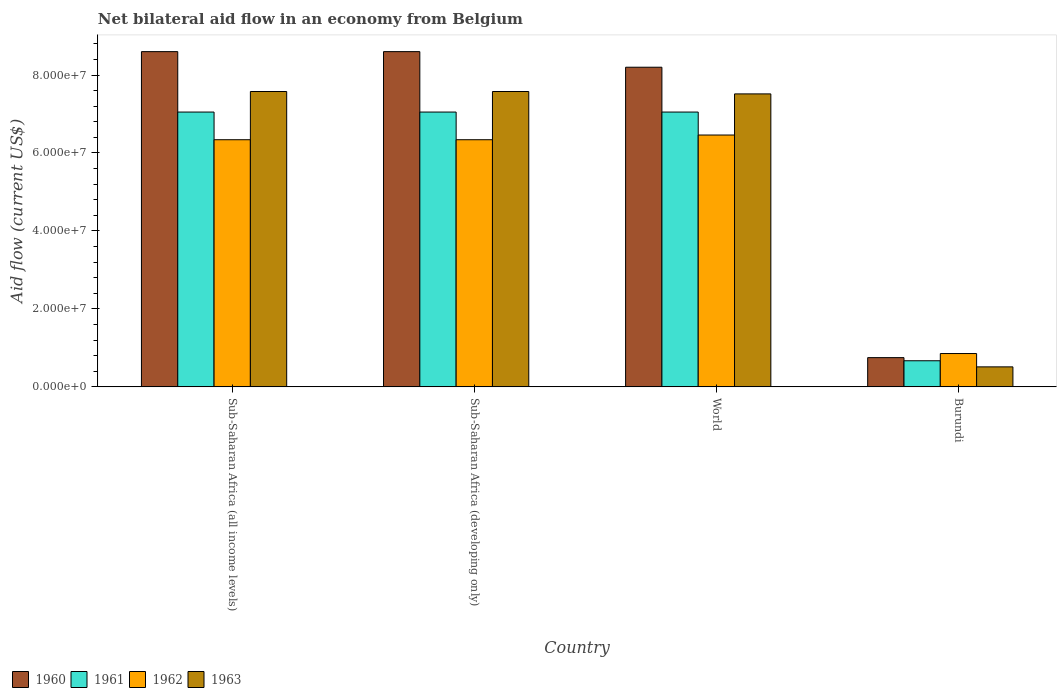How many different coloured bars are there?
Your answer should be very brief. 4. How many groups of bars are there?
Your response must be concise. 4. Are the number of bars per tick equal to the number of legend labels?
Offer a terse response. Yes. Are the number of bars on each tick of the X-axis equal?
Offer a terse response. Yes. In how many cases, is the number of bars for a given country not equal to the number of legend labels?
Make the answer very short. 0. What is the net bilateral aid flow in 1960 in Sub-Saharan Africa (all income levels)?
Provide a succinct answer. 8.60e+07. Across all countries, what is the maximum net bilateral aid flow in 1963?
Your response must be concise. 7.58e+07. Across all countries, what is the minimum net bilateral aid flow in 1963?
Your response must be concise. 5.13e+06. In which country was the net bilateral aid flow in 1962 maximum?
Your answer should be compact. World. In which country was the net bilateral aid flow in 1963 minimum?
Your response must be concise. Burundi. What is the total net bilateral aid flow in 1962 in the graph?
Provide a short and direct response. 2.00e+08. What is the difference between the net bilateral aid flow in 1961 in Sub-Saharan Africa (all income levels) and the net bilateral aid flow in 1960 in Sub-Saharan Africa (developing only)?
Your response must be concise. -1.55e+07. What is the average net bilateral aid flow in 1961 per country?
Provide a succinct answer. 5.46e+07. What is the difference between the net bilateral aid flow of/in 1961 and net bilateral aid flow of/in 1960 in Sub-Saharan Africa (all income levels)?
Ensure brevity in your answer.  -1.55e+07. What is the ratio of the net bilateral aid flow in 1961 in Burundi to that in World?
Your answer should be very brief. 0.1. Is the net bilateral aid flow in 1960 in Burundi less than that in Sub-Saharan Africa (developing only)?
Ensure brevity in your answer.  Yes. Is the difference between the net bilateral aid flow in 1961 in Sub-Saharan Africa (developing only) and World greater than the difference between the net bilateral aid flow in 1960 in Sub-Saharan Africa (developing only) and World?
Offer a very short reply. No. What is the difference between the highest and the second highest net bilateral aid flow in 1960?
Your answer should be compact. 4.00e+06. What is the difference between the highest and the lowest net bilateral aid flow in 1963?
Provide a short and direct response. 7.06e+07. In how many countries, is the net bilateral aid flow in 1961 greater than the average net bilateral aid flow in 1961 taken over all countries?
Your answer should be compact. 3. Is the sum of the net bilateral aid flow in 1960 in Burundi and Sub-Saharan Africa (developing only) greater than the maximum net bilateral aid flow in 1963 across all countries?
Offer a terse response. Yes. Is it the case that in every country, the sum of the net bilateral aid flow in 1960 and net bilateral aid flow in 1962 is greater than the sum of net bilateral aid flow in 1961 and net bilateral aid flow in 1963?
Make the answer very short. No. What does the 2nd bar from the left in Sub-Saharan Africa (all income levels) represents?
Ensure brevity in your answer.  1961. What does the 2nd bar from the right in Burundi represents?
Keep it short and to the point. 1962. Is it the case that in every country, the sum of the net bilateral aid flow in 1960 and net bilateral aid flow in 1961 is greater than the net bilateral aid flow in 1962?
Give a very brief answer. Yes. How many countries are there in the graph?
Provide a short and direct response. 4. What is the difference between two consecutive major ticks on the Y-axis?
Offer a very short reply. 2.00e+07. Does the graph contain any zero values?
Your answer should be very brief. No. Does the graph contain grids?
Give a very brief answer. No. How many legend labels are there?
Provide a succinct answer. 4. How are the legend labels stacked?
Make the answer very short. Horizontal. What is the title of the graph?
Offer a terse response. Net bilateral aid flow in an economy from Belgium. What is the label or title of the X-axis?
Provide a succinct answer. Country. What is the Aid flow (current US$) in 1960 in Sub-Saharan Africa (all income levels)?
Your answer should be compact. 8.60e+07. What is the Aid flow (current US$) of 1961 in Sub-Saharan Africa (all income levels)?
Offer a very short reply. 7.05e+07. What is the Aid flow (current US$) of 1962 in Sub-Saharan Africa (all income levels)?
Ensure brevity in your answer.  6.34e+07. What is the Aid flow (current US$) of 1963 in Sub-Saharan Africa (all income levels)?
Your response must be concise. 7.58e+07. What is the Aid flow (current US$) of 1960 in Sub-Saharan Africa (developing only)?
Provide a succinct answer. 8.60e+07. What is the Aid flow (current US$) of 1961 in Sub-Saharan Africa (developing only)?
Give a very brief answer. 7.05e+07. What is the Aid flow (current US$) in 1962 in Sub-Saharan Africa (developing only)?
Offer a terse response. 6.34e+07. What is the Aid flow (current US$) in 1963 in Sub-Saharan Africa (developing only)?
Offer a terse response. 7.58e+07. What is the Aid flow (current US$) of 1960 in World?
Offer a terse response. 8.20e+07. What is the Aid flow (current US$) of 1961 in World?
Your answer should be compact. 7.05e+07. What is the Aid flow (current US$) of 1962 in World?
Offer a very short reply. 6.46e+07. What is the Aid flow (current US$) in 1963 in World?
Your answer should be very brief. 7.52e+07. What is the Aid flow (current US$) of 1960 in Burundi?
Offer a very short reply. 7.50e+06. What is the Aid flow (current US$) in 1961 in Burundi?
Keep it short and to the point. 6.70e+06. What is the Aid flow (current US$) in 1962 in Burundi?
Ensure brevity in your answer.  8.55e+06. What is the Aid flow (current US$) of 1963 in Burundi?
Offer a very short reply. 5.13e+06. Across all countries, what is the maximum Aid flow (current US$) of 1960?
Offer a very short reply. 8.60e+07. Across all countries, what is the maximum Aid flow (current US$) in 1961?
Offer a terse response. 7.05e+07. Across all countries, what is the maximum Aid flow (current US$) of 1962?
Ensure brevity in your answer.  6.46e+07. Across all countries, what is the maximum Aid flow (current US$) of 1963?
Ensure brevity in your answer.  7.58e+07. Across all countries, what is the minimum Aid flow (current US$) of 1960?
Your response must be concise. 7.50e+06. Across all countries, what is the minimum Aid flow (current US$) in 1961?
Offer a very short reply. 6.70e+06. Across all countries, what is the minimum Aid flow (current US$) in 1962?
Offer a terse response. 8.55e+06. Across all countries, what is the minimum Aid flow (current US$) in 1963?
Ensure brevity in your answer.  5.13e+06. What is the total Aid flow (current US$) of 1960 in the graph?
Provide a succinct answer. 2.62e+08. What is the total Aid flow (current US$) of 1961 in the graph?
Your answer should be compact. 2.18e+08. What is the total Aid flow (current US$) of 1962 in the graph?
Ensure brevity in your answer.  2.00e+08. What is the total Aid flow (current US$) in 1963 in the graph?
Keep it short and to the point. 2.32e+08. What is the difference between the Aid flow (current US$) of 1960 in Sub-Saharan Africa (all income levels) and that in Sub-Saharan Africa (developing only)?
Your response must be concise. 0. What is the difference between the Aid flow (current US$) in 1961 in Sub-Saharan Africa (all income levels) and that in Sub-Saharan Africa (developing only)?
Ensure brevity in your answer.  0. What is the difference between the Aid flow (current US$) of 1962 in Sub-Saharan Africa (all income levels) and that in Sub-Saharan Africa (developing only)?
Offer a terse response. 0. What is the difference between the Aid flow (current US$) of 1963 in Sub-Saharan Africa (all income levels) and that in Sub-Saharan Africa (developing only)?
Ensure brevity in your answer.  0. What is the difference between the Aid flow (current US$) in 1960 in Sub-Saharan Africa (all income levels) and that in World?
Give a very brief answer. 4.00e+06. What is the difference between the Aid flow (current US$) of 1961 in Sub-Saharan Africa (all income levels) and that in World?
Give a very brief answer. 0. What is the difference between the Aid flow (current US$) in 1962 in Sub-Saharan Africa (all income levels) and that in World?
Provide a succinct answer. -1.21e+06. What is the difference between the Aid flow (current US$) in 1963 in Sub-Saharan Africa (all income levels) and that in World?
Provide a succinct answer. 6.10e+05. What is the difference between the Aid flow (current US$) of 1960 in Sub-Saharan Africa (all income levels) and that in Burundi?
Give a very brief answer. 7.85e+07. What is the difference between the Aid flow (current US$) in 1961 in Sub-Saharan Africa (all income levels) and that in Burundi?
Provide a short and direct response. 6.38e+07. What is the difference between the Aid flow (current US$) in 1962 in Sub-Saharan Africa (all income levels) and that in Burundi?
Your answer should be very brief. 5.48e+07. What is the difference between the Aid flow (current US$) in 1963 in Sub-Saharan Africa (all income levels) and that in Burundi?
Provide a succinct answer. 7.06e+07. What is the difference between the Aid flow (current US$) of 1960 in Sub-Saharan Africa (developing only) and that in World?
Provide a short and direct response. 4.00e+06. What is the difference between the Aid flow (current US$) in 1962 in Sub-Saharan Africa (developing only) and that in World?
Your response must be concise. -1.21e+06. What is the difference between the Aid flow (current US$) in 1963 in Sub-Saharan Africa (developing only) and that in World?
Your answer should be very brief. 6.10e+05. What is the difference between the Aid flow (current US$) of 1960 in Sub-Saharan Africa (developing only) and that in Burundi?
Your answer should be very brief. 7.85e+07. What is the difference between the Aid flow (current US$) in 1961 in Sub-Saharan Africa (developing only) and that in Burundi?
Your answer should be very brief. 6.38e+07. What is the difference between the Aid flow (current US$) of 1962 in Sub-Saharan Africa (developing only) and that in Burundi?
Provide a succinct answer. 5.48e+07. What is the difference between the Aid flow (current US$) in 1963 in Sub-Saharan Africa (developing only) and that in Burundi?
Provide a succinct answer. 7.06e+07. What is the difference between the Aid flow (current US$) of 1960 in World and that in Burundi?
Offer a terse response. 7.45e+07. What is the difference between the Aid flow (current US$) in 1961 in World and that in Burundi?
Offer a very short reply. 6.38e+07. What is the difference between the Aid flow (current US$) of 1962 in World and that in Burundi?
Your answer should be very brief. 5.61e+07. What is the difference between the Aid flow (current US$) in 1963 in World and that in Burundi?
Offer a very short reply. 7.00e+07. What is the difference between the Aid flow (current US$) in 1960 in Sub-Saharan Africa (all income levels) and the Aid flow (current US$) in 1961 in Sub-Saharan Africa (developing only)?
Offer a terse response. 1.55e+07. What is the difference between the Aid flow (current US$) in 1960 in Sub-Saharan Africa (all income levels) and the Aid flow (current US$) in 1962 in Sub-Saharan Africa (developing only)?
Your answer should be very brief. 2.26e+07. What is the difference between the Aid flow (current US$) of 1960 in Sub-Saharan Africa (all income levels) and the Aid flow (current US$) of 1963 in Sub-Saharan Africa (developing only)?
Offer a terse response. 1.02e+07. What is the difference between the Aid flow (current US$) in 1961 in Sub-Saharan Africa (all income levels) and the Aid flow (current US$) in 1962 in Sub-Saharan Africa (developing only)?
Offer a terse response. 7.10e+06. What is the difference between the Aid flow (current US$) in 1961 in Sub-Saharan Africa (all income levels) and the Aid flow (current US$) in 1963 in Sub-Saharan Africa (developing only)?
Keep it short and to the point. -5.27e+06. What is the difference between the Aid flow (current US$) in 1962 in Sub-Saharan Africa (all income levels) and the Aid flow (current US$) in 1963 in Sub-Saharan Africa (developing only)?
Provide a succinct answer. -1.24e+07. What is the difference between the Aid flow (current US$) of 1960 in Sub-Saharan Africa (all income levels) and the Aid flow (current US$) of 1961 in World?
Your answer should be compact. 1.55e+07. What is the difference between the Aid flow (current US$) in 1960 in Sub-Saharan Africa (all income levels) and the Aid flow (current US$) in 1962 in World?
Provide a succinct answer. 2.14e+07. What is the difference between the Aid flow (current US$) in 1960 in Sub-Saharan Africa (all income levels) and the Aid flow (current US$) in 1963 in World?
Provide a short and direct response. 1.08e+07. What is the difference between the Aid flow (current US$) of 1961 in Sub-Saharan Africa (all income levels) and the Aid flow (current US$) of 1962 in World?
Ensure brevity in your answer.  5.89e+06. What is the difference between the Aid flow (current US$) of 1961 in Sub-Saharan Africa (all income levels) and the Aid flow (current US$) of 1963 in World?
Ensure brevity in your answer.  -4.66e+06. What is the difference between the Aid flow (current US$) of 1962 in Sub-Saharan Africa (all income levels) and the Aid flow (current US$) of 1963 in World?
Offer a very short reply. -1.18e+07. What is the difference between the Aid flow (current US$) in 1960 in Sub-Saharan Africa (all income levels) and the Aid flow (current US$) in 1961 in Burundi?
Your response must be concise. 7.93e+07. What is the difference between the Aid flow (current US$) of 1960 in Sub-Saharan Africa (all income levels) and the Aid flow (current US$) of 1962 in Burundi?
Keep it short and to the point. 7.74e+07. What is the difference between the Aid flow (current US$) of 1960 in Sub-Saharan Africa (all income levels) and the Aid flow (current US$) of 1963 in Burundi?
Give a very brief answer. 8.09e+07. What is the difference between the Aid flow (current US$) in 1961 in Sub-Saharan Africa (all income levels) and the Aid flow (current US$) in 1962 in Burundi?
Make the answer very short. 6.20e+07. What is the difference between the Aid flow (current US$) of 1961 in Sub-Saharan Africa (all income levels) and the Aid flow (current US$) of 1963 in Burundi?
Your answer should be very brief. 6.54e+07. What is the difference between the Aid flow (current US$) in 1962 in Sub-Saharan Africa (all income levels) and the Aid flow (current US$) in 1963 in Burundi?
Offer a very short reply. 5.83e+07. What is the difference between the Aid flow (current US$) of 1960 in Sub-Saharan Africa (developing only) and the Aid flow (current US$) of 1961 in World?
Provide a succinct answer. 1.55e+07. What is the difference between the Aid flow (current US$) in 1960 in Sub-Saharan Africa (developing only) and the Aid flow (current US$) in 1962 in World?
Make the answer very short. 2.14e+07. What is the difference between the Aid flow (current US$) in 1960 in Sub-Saharan Africa (developing only) and the Aid flow (current US$) in 1963 in World?
Ensure brevity in your answer.  1.08e+07. What is the difference between the Aid flow (current US$) in 1961 in Sub-Saharan Africa (developing only) and the Aid flow (current US$) in 1962 in World?
Give a very brief answer. 5.89e+06. What is the difference between the Aid flow (current US$) of 1961 in Sub-Saharan Africa (developing only) and the Aid flow (current US$) of 1963 in World?
Make the answer very short. -4.66e+06. What is the difference between the Aid flow (current US$) in 1962 in Sub-Saharan Africa (developing only) and the Aid flow (current US$) in 1963 in World?
Give a very brief answer. -1.18e+07. What is the difference between the Aid flow (current US$) in 1960 in Sub-Saharan Africa (developing only) and the Aid flow (current US$) in 1961 in Burundi?
Offer a very short reply. 7.93e+07. What is the difference between the Aid flow (current US$) in 1960 in Sub-Saharan Africa (developing only) and the Aid flow (current US$) in 1962 in Burundi?
Your answer should be very brief. 7.74e+07. What is the difference between the Aid flow (current US$) in 1960 in Sub-Saharan Africa (developing only) and the Aid flow (current US$) in 1963 in Burundi?
Make the answer very short. 8.09e+07. What is the difference between the Aid flow (current US$) of 1961 in Sub-Saharan Africa (developing only) and the Aid flow (current US$) of 1962 in Burundi?
Offer a terse response. 6.20e+07. What is the difference between the Aid flow (current US$) in 1961 in Sub-Saharan Africa (developing only) and the Aid flow (current US$) in 1963 in Burundi?
Ensure brevity in your answer.  6.54e+07. What is the difference between the Aid flow (current US$) in 1962 in Sub-Saharan Africa (developing only) and the Aid flow (current US$) in 1963 in Burundi?
Provide a short and direct response. 5.83e+07. What is the difference between the Aid flow (current US$) of 1960 in World and the Aid flow (current US$) of 1961 in Burundi?
Give a very brief answer. 7.53e+07. What is the difference between the Aid flow (current US$) in 1960 in World and the Aid flow (current US$) in 1962 in Burundi?
Ensure brevity in your answer.  7.34e+07. What is the difference between the Aid flow (current US$) of 1960 in World and the Aid flow (current US$) of 1963 in Burundi?
Keep it short and to the point. 7.69e+07. What is the difference between the Aid flow (current US$) in 1961 in World and the Aid flow (current US$) in 1962 in Burundi?
Ensure brevity in your answer.  6.20e+07. What is the difference between the Aid flow (current US$) of 1961 in World and the Aid flow (current US$) of 1963 in Burundi?
Your response must be concise. 6.54e+07. What is the difference between the Aid flow (current US$) in 1962 in World and the Aid flow (current US$) in 1963 in Burundi?
Provide a short and direct response. 5.95e+07. What is the average Aid flow (current US$) in 1960 per country?
Your answer should be very brief. 6.54e+07. What is the average Aid flow (current US$) of 1961 per country?
Your answer should be compact. 5.46e+07. What is the average Aid flow (current US$) in 1962 per country?
Your response must be concise. 5.00e+07. What is the average Aid flow (current US$) of 1963 per country?
Ensure brevity in your answer.  5.80e+07. What is the difference between the Aid flow (current US$) of 1960 and Aid flow (current US$) of 1961 in Sub-Saharan Africa (all income levels)?
Your response must be concise. 1.55e+07. What is the difference between the Aid flow (current US$) in 1960 and Aid flow (current US$) in 1962 in Sub-Saharan Africa (all income levels)?
Provide a succinct answer. 2.26e+07. What is the difference between the Aid flow (current US$) in 1960 and Aid flow (current US$) in 1963 in Sub-Saharan Africa (all income levels)?
Offer a terse response. 1.02e+07. What is the difference between the Aid flow (current US$) in 1961 and Aid flow (current US$) in 1962 in Sub-Saharan Africa (all income levels)?
Provide a short and direct response. 7.10e+06. What is the difference between the Aid flow (current US$) in 1961 and Aid flow (current US$) in 1963 in Sub-Saharan Africa (all income levels)?
Your answer should be compact. -5.27e+06. What is the difference between the Aid flow (current US$) in 1962 and Aid flow (current US$) in 1963 in Sub-Saharan Africa (all income levels)?
Offer a terse response. -1.24e+07. What is the difference between the Aid flow (current US$) in 1960 and Aid flow (current US$) in 1961 in Sub-Saharan Africa (developing only)?
Your answer should be very brief. 1.55e+07. What is the difference between the Aid flow (current US$) in 1960 and Aid flow (current US$) in 1962 in Sub-Saharan Africa (developing only)?
Provide a succinct answer. 2.26e+07. What is the difference between the Aid flow (current US$) in 1960 and Aid flow (current US$) in 1963 in Sub-Saharan Africa (developing only)?
Provide a short and direct response. 1.02e+07. What is the difference between the Aid flow (current US$) of 1961 and Aid flow (current US$) of 1962 in Sub-Saharan Africa (developing only)?
Offer a very short reply. 7.10e+06. What is the difference between the Aid flow (current US$) of 1961 and Aid flow (current US$) of 1963 in Sub-Saharan Africa (developing only)?
Make the answer very short. -5.27e+06. What is the difference between the Aid flow (current US$) in 1962 and Aid flow (current US$) in 1963 in Sub-Saharan Africa (developing only)?
Keep it short and to the point. -1.24e+07. What is the difference between the Aid flow (current US$) in 1960 and Aid flow (current US$) in 1961 in World?
Keep it short and to the point. 1.15e+07. What is the difference between the Aid flow (current US$) in 1960 and Aid flow (current US$) in 1962 in World?
Your response must be concise. 1.74e+07. What is the difference between the Aid flow (current US$) of 1960 and Aid flow (current US$) of 1963 in World?
Keep it short and to the point. 6.84e+06. What is the difference between the Aid flow (current US$) in 1961 and Aid flow (current US$) in 1962 in World?
Offer a terse response. 5.89e+06. What is the difference between the Aid flow (current US$) of 1961 and Aid flow (current US$) of 1963 in World?
Offer a terse response. -4.66e+06. What is the difference between the Aid flow (current US$) of 1962 and Aid flow (current US$) of 1963 in World?
Keep it short and to the point. -1.06e+07. What is the difference between the Aid flow (current US$) in 1960 and Aid flow (current US$) in 1962 in Burundi?
Your answer should be very brief. -1.05e+06. What is the difference between the Aid flow (current US$) in 1960 and Aid flow (current US$) in 1963 in Burundi?
Your answer should be compact. 2.37e+06. What is the difference between the Aid flow (current US$) of 1961 and Aid flow (current US$) of 1962 in Burundi?
Make the answer very short. -1.85e+06. What is the difference between the Aid flow (current US$) of 1961 and Aid flow (current US$) of 1963 in Burundi?
Provide a short and direct response. 1.57e+06. What is the difference between the Aid flow (current US$) in 1962 and Aid flow (current US$) in 1963 in Burundi?
Your response must be concise. 3.42e+06. What is the ratio of the Aid flow (current US$) in 1960 in Sub-Saharan Africa (all income levels) to that in Sub-Saharan Africa (developing only)?
Make the answer very short. 1. What is the ratio of the Aid flow (current US$) of 1962 in Sub-Saharan Africa (all income levels) to that in Sub-Saharan Africa (developing only)?
Keep it short and to the point. 1. What is the ratio of the Aid flow (current US$) of 1963 in Sub-Saharan Africa (all income levels) to that in Sub-Saharan Africa (developing only)?
Offer a terse response. 1. What is the ratio of the Aid flow (current US$) in 1960 in Sub-Saharan Africa (all income levels) to that in World?
Provide a short and direct response. 1.05. What is the ratio of the Aid flow (current US$) in 1961 in Sub-Saharan Africa (all income levels) to that in World?
Keep it short and to the point. 1. What is the ratio of the Aid flow (current US$) in 1962 in Sub-Saharan Africa (all income levels) to that in World?
Give a very brief answer. 0.98. What is the ratio of the Aid flow (current US$) of 1960 in Sub-Saharan Africa (all income levels) to that in Burundi?
Give a very brief answer. 11.47. What is the ratio of the Aid flow (current US$) in 1961 in Sub-Saharan Africa (all income levels) to that in Burundi?
Provide a succinct answer. 10.52. What is the ratio of the Aid flow (current US$) of 1962 in Sub-Saharan Africa (all income levels) to that in Burundi?
Keep it short and to the point. 7.42. What is the ratio of the Aid flow (current US$) of 1963 in Sub-Saharan Africa (all income levels) to that in Burundi?
Your response must be concise. 14.77. What is the ratio of the Aid flow (current US$) in 1960 in Sub-Saharan Africa (developing only) to that in World?
Keep it short and to the point. 1.05. What is the ratio of the Aid flow (current US$) in 1962 in Sub-Saharan Africa (developing only) to that in World?
Keep it short and to the point. 0.98. What is the ratio of the Aid flow (current US$) of 1960 in Sub-Saharan Africa (developing only) to that in Burundi?
Ensure brevity in your answer.  11.47. What is the ratio of the Aid flow (current US$) in 1961 in Sub-Saharan Africa (developing only) to that in Burundi?
Your answer should be very brief. 10.52. What is the ratio of the Aid flow (current US$) of 1962 in Sub-Saharan Africa (developing only) to that in Burundi?
Your response must be concise. 7.42. What is the ratio of the Aid flow (current US$) in 1963 in Sub-Saharan Africa (developing only) to that in Burundi?
Give a very brief answer. 14.77. What is the ratio of the Aid flow (current US$) in 1960 in World to that in Burundi?
Keep it short and to the point. 10.93. What is the ratio of the Aid flow (current US$) in 1961 in World to that in Burundi?
Give a very brief answer. 10.52. What is the ratio of the Aid flow (current US$) in 1962 in World to that in Burundi?
Provide a short and direct response. 7.56. What is the ratio of the Aid flow (current US$) of 1963 in World to that in Burundi?
Make the answer very short. 14.65. What is the difference between the highest and the second highest Aid flow (current US$) in 1960?
Ensure brevity in your answer.  0. What is the difference between the highest and the second highest Aid flow (current US$) in 1962?
Give a very brief answer. 1.21e+06. What is the difference between the highest and the lowest Aid flow (current US$) in 1960?
Your response must be concise. 7.85e+07. What is the difference between the highest and the lowest Aid flow (current US$) in 1961?
Your response must be concise. 6.38e+07. What is the difference between the highest and the lowest Aid flow (current US$) of 1962?
Your answer should be very brief. 5.61e+07. What is the difference between the highest and the lowest Aid flow (current US$) in 1963?
Make the answer very short. 7.06e+07. 